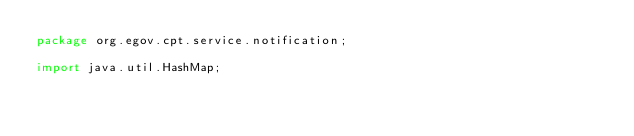Convert code to text. <code><loc_0><loc_0><loc_500><loc_500><_Java_>package org.egov.cpt.service.notification;

import java.util.HashMap;</code> 